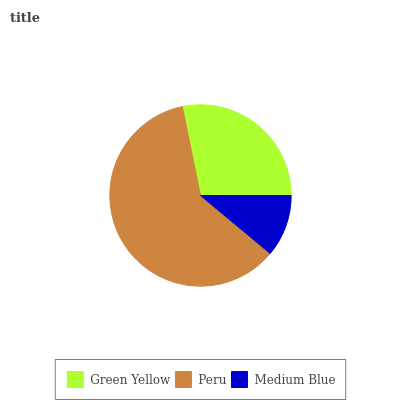Is Medium Blue the minimum?
Answer yes or no. Yes. Is Peru the maximum?
Answer yes or no. Yes. Is Peru the minimum?
Answer yes or no. No. Is Medium Blue the maximum?
Answer yes or no. No. Is Peru greater than Medium Blue?
Answer yes or no. Yes. Is Medium Blue less than Peru?
Answer yes or no. Yes. Is Medium Blue greater than Peru?
Answer yes or no. No. Is Peru less than Medium Blue?
Answer yes or no. No. Is Green Yellow the high median?
Answer yes or no. Yes. Is Green Yellow the low median?
Answer yes or no. Yes. Is Peru the high median?
Answer yes or no. No. Is Medium Blue the low median?
Answer yes or no. No. 